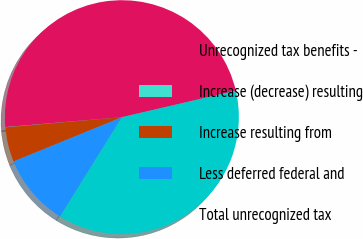<chart> <loc_0><loc_0><loc_500><loc_500><pie_chart><fcel>Unrecognized tax benefits -<fcel>Increase (decrease) resulting<fcel>Increase resulting from<fcel>Less deferred federal and<fcel>Total unrecognized tax<nl><fcel>47.71%<fcel>0.04%<fcel>4.78%<fcel>9.97%<fcel>37.5%<nl></chart> 